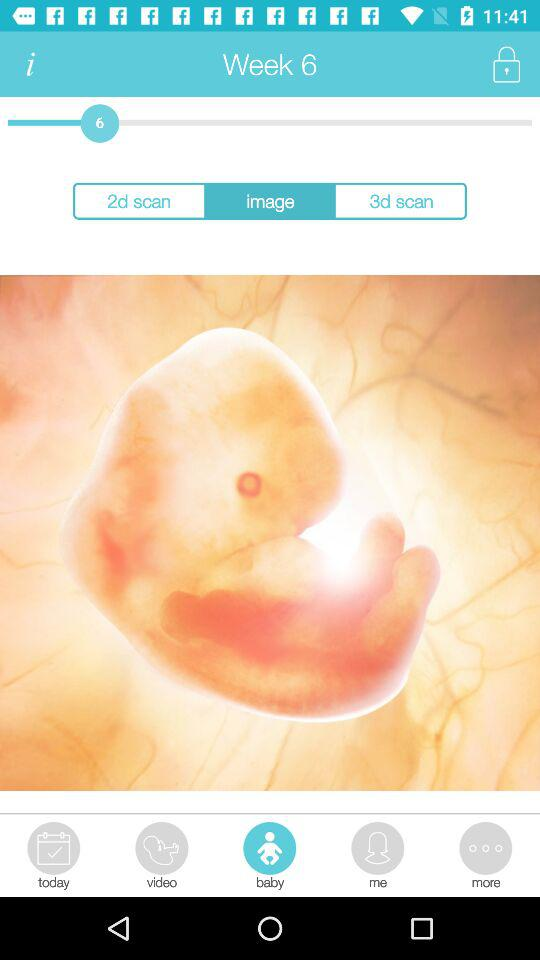What week is it? It is week 6. 